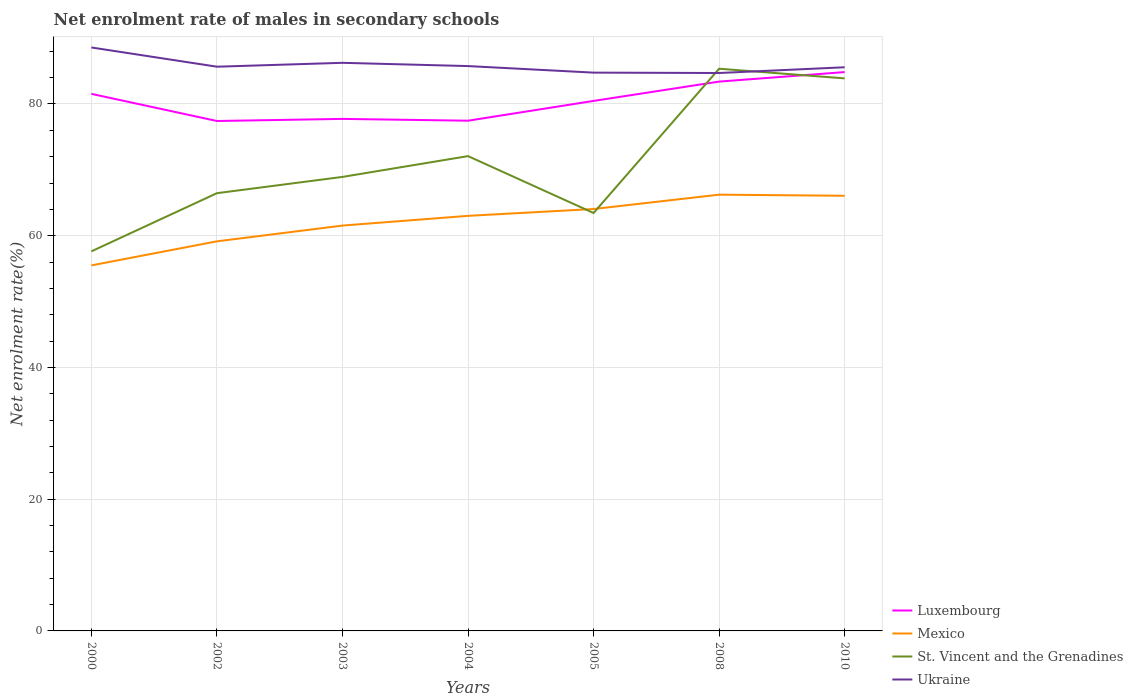How many different coloured lines are there?
Your response must be concise. 4. Does the line corresponding to St. Vincent and the Grenadines intersect with the line corresponding to Luxembourg?
Provide a short and direct response. Yes. Is the number of lines equal to the number of legend labels?
Offer a very short reply. Yes. Across all years, what is the maximum net enrolment rate of males in secondary schools in Mexico?
Your answer should be compact. 55.49. What is the total net enrolment rate of males in secondary schools in Mexico in the graph?
Give a very brief answer. 0.17. What is the difference between the highest and the second highest net enrolment rate of males in secondary schools in Luxembourg?
Your answer should be very brief. 7.42. Is the net enrolment rate of males in secondary schools in St. Vincent and the Grenadines strictly greater than the net enrolment rate of males in secondary schools in Luxembourg over the years?
Your answer should be compact. No. How many lines are there?
Offer a very short reply. 4. How many years are there in the graph?
Ensure brevity in your answer.  7. What is the difference between two consecutive major ticks on the Y-axis?
Make the answer very short. 20. Are the values on the major ticks of Y-axis written in scientific E-notation?
Your answer should be compact. No. Does the graph contain any zero values?
Give a very brief answer. No. Does the graph contain grids?
Ensure brevity in your answer.  Yes. How many legend labels are there?
Keep it short and to the point. 4. What is the title of the graph?
Make the answer very short. Net enrolment rate of males in secondary schools. What is the label or title of the Y-axis?
Your answer should be compact. Net enrolment rate(%). What is the Net enrolment rate(%) in Luxembourg in 2000?
Ensure brevity in your answer.  81.53. What is the Net enrolment rate(%) in Mexico in 2000?
Offer a very short reply. 55.49. What is the Net enrolment rate(%) of St. Vincent and the Grenadines in 2000?
Offer a very short reply. 57.63. What is the Net enrolment rate(%) of Ukraine in 2000?
Your answer should be very brief. 88.58. What is the Net enrolment rate(%) of Luxembourg in 2002?
Ensure brevity in your answer.  77.42. What is the Net enrolment rate(%) in Mexico in 2002?
Give a very brief answer. 59.15. What is the Net enrolment rate(%) in St. Vincent and the Grenadines in 2002?
Provide a succinct answer. 66.46. What is the Net enrolment rate(%) in Ukraine in 2002?
Offer a terse response. 85.66. What is the Net enrolment rate(%) in Luxembourg in 2003?
Give a very brief answer. 77.73. What is the Net enrolment rate(%) in Mexico in 2003?
Keep it short and to the point. 61.54. What is the Net enrolment rate(%) of St. Vincent and the Grenadines in 2003?
Provide a succinct answer. 68.93. What is the Net enrolment rate(%) of Ukraine in 2003?
Your answer should be very brief. 86.25. What is the Net enrolment rate(%) in Luxembourg in 2004?
Your answer should be very brief. 77.46. What is the Net enrolment rate(%) of Mexico in 2004?
Your answer should be compact. 63.02. What is the Net enrolment rate(%) in St. Vincent and the Grenadines in 2004?
Your response must be concise. 72.08. What is the Net enrolment rate(%) of Ukraine in 2004?
Your answer should be compact. 85.75. What is the Net enrolment rate(%) of Luxembourg in 2005?
Make the answer very short. 80.46. What is the Net enrolment rate(%) in Mexico in 2005?
Ensure brevity in your answer.  64.05. What is the Net enrolment rate(%) of St. Vincent and the Grenadines in 2005?
Your answer should be very brief. 63.45. What is the Net enrolment rate(%) of Ukraine in 2005?
Give a very brief answer. 84.76. What is the Net enrolment rate(%) in Luxembourg in 2008?
Offer a terse response. 83.4. What is the Net enrolment rate(%) of Mexico in 2008?
Keep it short and to the point. 66.23. What is the Net enrolment rate(%) of St. Vincent and the Grenadines in 2008?
Ensure brevity in your answer.  85.35. What is the Net enrolment rate(%) of Ukraine in 2008?
Keep it short and to the point. 84.7. What is the Net enrolment rate(%) in Luxembourg in 2010?
Provide a short and direct response. 84.84. What is the Net enrolment rate(%) in Mexico in 2010?
Offer a terse response. 66.06. What is the Net enrolment rate(%) of St. Vincent and the Grenadines in 2010?
Provide a short and direct response. 83.89. What is the Net enrolment rate(%) of Ukraine in 2010?
Make the answer very short. 85.57. Across all years, what is the maximum Net enrolment rate(%) in Luxembourg?
Give a very brief answer. 84.84. Across all years, what is the maximum Net enrolment rate(%) in Mexico?
Make the answer very short. 66.23. Across all years, what is the maximum Net enrolment rate(%) of St. Vincent and the Grenadines?
Provide a succinct answer. 85.35. Across all years, what is the maximum Net enrolment rate(%) of Ukraine?
Your answer should be compact. 88.58. Across all years, what is the minimum Net enrolment rate(%) of Luxembourg?
Make the answer very short. 77.42. Across all years, what is the minimum Net enrolment rate(%) in Mexico?
Your response must be concise. 55.49. Across all years, what is the minimum Net enrolment rate(%) in St. Vincent and the Grenadines?
Provide a short and direct response. 57.63. Across all years, what is the minimum Net enrolment rate(%) in Ukraine?
Keep it short and to the point. 84.7. What is the total Net enrolment rate(%) in Luxembourg in the graph?
Provide a short and direct response. 562.84. What is the total Net enrolment rate(%) of Mexico in the graph?
Your response must be concise. 435.54. What is the total Net enrolment rate(%) of St. Vincent and the Grenadines in the graph?
Make the answer very short. 497.78. What is the total Net enrolment rate(%) of Ukraine in the graph?
Give a very brief answer. 601.27. What is the difference between the Net enrolment rate(%) in Luxembourg in 2000 and that in 2002?
Offer a terse response. 4.12. What is the difference between the Net enrolment rate(%) in Mexico in 2000 and that in 2002?
Ensure brevity in your answer.  -3.65. What is the difference between the Net enrolment rate(%) in St. Vincent and the Grenadines in 2000 and that in 2002?
Offer a very short reply. -8.83. What is the difference between the Net enrolment rate(%) of Ukraine in 2000 and that in 2002?
Your answer should be compact. 2.92. What is the difference between the Net enrolment rate(%) of Luxembourg in 2000 and that in 2003?
Your answer should be compact. 3.8. What is the difference between the Net enrolment rate(%) in Mexico in 2000 and that in 2003?
Keep it short and to the point. -6.05. What is the difference between the Net enrolment rate(%) in St. Vincent and the Grenadines in 2000 and that in 2003?
Offer a terse response. -11.3. What is the difference between the Net enrolment rate(%) in Ukraine in 2000 and that in 2003?
Offer a very short reply. 2.33. What is the difference between the Net enrolment rate(%) in Luxembourg in 2000 and that in 2004?
Give a very brief answer. 4.07. What is the difference between the Net enrolment rate(%) in Mexico in 2000 and that in 2004?
Your response must be concise. -7.52. What is the difference between the Net enrolment rate(%) of St. Vincent and the Grenadines in 2000 and that in 2004?
Give a very brief answer. -14.46. What is the difference between the Net enrolment rate(%) in Ukraine in 2000 and that in 2004?
Keep it short and to the point. 2.83. What is the difference between the Net enrolment rate(%) of Luxembourg in 2000 and that in 2005?
Keep it short and to the point. 1.07. What is the difference between the Net enrolment rate(%) of Mexico in 2000 and that in 2005?
Make the answer very short. -8.56. What is the difference between the Net enrolment rate(%) of St. Vincent and the Grenadines in 2000 and that in 2005?
Offer a terse response. -5.82. What is the difference between the Net enrolment rate(%) in Ukraine in 2000 and that in 2005?
Offer a very short reply. 3.82. What is the difference between the Net enrolment rate(%) in Luxembourg in 2000 and that in 2008?
Your response must be concise. -1.86. What is the difference between the Net enrolment rate(%) in Mexico in 2000 and that in 2008?
Your answer should be compact. -10.74. What is the difference between the Net enrolment rate(%) in St. Vincent and the Grenadines in 2000 and that in 2008?
Provide a succinct answer. -27.73. What is the difference between the Net enrolment rate(%) in Ukraine in 2000 and that in 2008?
Ensure brevity in your answer.  3.87. What is the difference between the Net enrolment rate(%) in Luxembourg in 2000 and that in 2010?
Make the answer very short. -3.31. What is the difference between the Net enrolment rate(%) of Mexico in 2000 and that in 2010?
Keep it short and to the point. -10.57. What is the difference between the Net enrolment rate(%) in St. Vincent and the Grenadines in 2000 and that in 2010?
Your answer should be very brief. -26.26. What is the difference between the Net enrolment rate(%) of Ukraine in 2000 and that in 2010?
Provide a short and direct response. 3.01. What is the difference between the Net enrolment rate(%) in Luxembourg in 2002 and that in 2003?
Offer a very short reply. -0.32. What is the difference between the Net enrolment rate(%) in Mexico in 2002 and that in 2003?
Your response must be concise. -2.39. What is the difference between the Net enrolment rate(%) of St. Vincent and the Grenadines in 2002 and that in 2003?
Your answer should be compact. -2.47. What is the difference between the Net enrolment rate(%) of Ukraine in 2002 and that in 2003?
Your answer should be very brief. -0.59. What is the difference between the Net enrolment rate(%) of Luxembourg in 2002 and that in 2004?
Provide a succinct answer. -0.04. What is the difference between the Net enrolment rate(%) of Mexico in 2002 and that in 2004?
Your response must be concise. -3.87. What is the difference between the Net enrolment rate(%) of St. Vincent and the Grenadines in 2002 and that in 2004?
Offer a terse response. -5.63. What is the difference between the Net enrolment rate(%) of Ukraine in 2002 and that in 2004?
Your answer should be very brief. -0.09. What is the difference between the Net enrolment rate(%) in Luxembourg in 2002 and that in 2005?
Provide a short and direct response. -3.05. What is the difference between the Net enrolment rate(%) in Mexico in 2002 and that in 2005?
Offer a terse response. -4.91. What is the difference between the Net enrolment rate(%) of St. Vincent and the Grenadines in 2002 and that in 2005?
Keep it short and to the point. 3.01. What is the difference between the Net enrolment rate(%) in Ukraine in 2002 and that in 2005?
Provide a short and direct response. 0.9. What is the difference between the Net enrolment rate(%) in Luxembourg in 2002 and that in 2008?
Provide a short and direct response. -5.98. What is the difference between the Net enrolment rate(%) in Mexico in 2002 and that in 2008?
Make the answer very short. -7.08. What is the difference between the Net enrolment rate(%) in St. Vincent and the Grenadines in 2002 and that in 2008?
Your response must be concise. -18.89. What is the difference between the Net enrolment rate(%) of Ukraine in 2002 and that in 2008?
Your answer should be compact. 0.96. What is the difference between the Net enrolment rate(%) in Luxembourg in 2002 and that in 2010?
Ensure brevity in your answer.  -7.42. What is the difference between the Net enrolment rate(%) in Mexico in 2002 and that in 2010?
Your answer should be very brief. -6.92. What is the difference between the Net enrolment rate(%) in St. Vincent and the Grenadines in 2002 and that in 2010?
Your answer should be compact. -17.43. What is the difference between the Net enrolment rate(%) of Ukraine in 2002 and that in 2010?
Ensure brevity in your answer.  0.09. What is the difference between the Net enrolment rate(%) in Luxembourg in 2003 and that in 2004?
Ensure brevity in your answer.  0.28. What is the difference between the Net enrolment rate(%) of Mexico in 2003 and that in 2004?
Make the answer very short. -1.48. What is the difference between the Net enrolment rate(%) in St. Vincent and the Grenadines in 2003 and that in 2004?
Provide a succinct answer. -3.16. What is the difference between the Net enrolment rate(%) in Ukraine in 2003 and that in 2004?
Keep it short and to the point. 0.5. What is the difference between the Net enrolment rate(%) in Luxembourg in 2003 and that in 2005?
Your answer should be very brief. -2.73. What is the difference between the Net enrolment rate(%) of Mexico in 2003 and that in 2005?
Give a very brief answer. -2.51. What is the difference between the Net enrolment rate(%) in St. Vincent and the Grenadines in 2003 and that in 2005?
Your response must be concise. 5.48. What is the difference between the Net enrolment rate(%) of Ukraine in 2003 and that in 2005?
Offer a very short reply. 1.49. What is the difference between the Net enrolment rate(%) of Luxembourg in 2003 and that in 2008?
Provide a short and direct response. -5.66. What is the difference between the Net enrolment rate(%) of Mexico in 2003 and that in 2008?
Give a very brief answer. -4.69. What is the difference between the Net enrolment rate(%) in St. Vincent and the Grenadines in 2003 and that in 2008?
Give a very brief answer. -16.42. What is the difference between the Net enrolment rate(%) in Ukraine in 2003 and that in 2008?
Make the answer very short. 1.54. What is the difference between the Net enrolment rate(%) of Luxembourg in 2003 and that in 2010?
Make the answer very short. -7.11. What is the difference between the Net enrolment rate(%) of Mexico in 2003 and that in 2010?
Ensure brevity in your answer.  -4.53. What is the difference between the Net enrolment rate(%) in St. Vincent and the Grenadines in 2003 and that in 2010?
Keep it short and to the point. -14.96. What is the difference between the Net enrolment rate(%) in Ukraine in 2003 and that in 2010?
Offer a terse response. 0.68. What is the difference between the Net enrolment rate(%) in Luxembourg in 2004 and that in 2005?
Give a very brief answer. -3.01. What is the difference between the Net enrolment rate(%) of Mexico in 2004 and that in 2005?
Provide a succinct answer. -1.04. What is the difference between the Net enrolment rate(%) of St. Vincent and the Grenadines in 2004 and that in 2005?
Your answer should be very brief. 8.64. What is the difference between the Net enrolment rate(%) in Ukraine in 2004 and that in 2005?
Provide a short and direct response. 0.99. What is the difference between the Net enrolment rate(%) in Luxembourg in 2004 and that in 2008?
Give a very brief answer. -5.94. What is the difference between the Net enrolment rate(%) of Mexico in 2004 and that in 2008?
Provide a short and direct response. -3.21. What is the difference between the Net enrolment rate(%) of St. Vincent and the Grenadines in 2004 and that in 2008?
Your answer should be compact. -13.27. What is the difference between the Net enrolment rate(%) of Ukraine in 2004 and that in 2008?
Your answer should be very brief. 1.05. What is the difference between the Net enrolment rate(%) in Luxembourg in 2004 and that in 2010?
Your response must be concise. -7.38. What is the difference between the Net enrolment rate(%) in Mexico in 2004 and that in 2010?
Give a very brief answer. -3.05. What is the difference between the Net enrolment rate(%) of St. Vincent and the Grenadines in 2004 and that in 2010?
Give a very brief answer. -11.8. What is the difference between the Net enrolment rate(%) of Ukraine in 2004 and that in 2010?
Make the answer very short. 0.18. What is the difference between the Net enrolment rate(%) of Luxembourg in 2005 and that in 2008?
Your answer should be compact. -2.93. What is the difference between the Net enrolment rate(%) of Mexico in 2005 and that in 2008?
Your response must be concise. -2.18. What is the difference between the Net enrolment rate(%) in St. Vincent and the Grenadines in 2005 and that in 2008?
Keep it short and to the point. -21.9. What is the difference between the Net enrolment rate(%) of Ukraine in 2005 and that in 2008?
Your answer should be very brief. 0.06. What is the difference between the Net enrolment rate(%) in Luxembourg in 2005 and that in 2010?
Offer a terse response. -4.38. What is the difference between the Net enrolment rate(%) in Mexico in 2005 and that in 2010?
Provide a short and direct response. -2.01. What is the difference between the Net enrolment rate(%) of St. Vincent and the Grenadines in 2005 and that in 2010?
Your answer should be very brief. -20.44. What is the difference between the Net enrolment rate(%) in Ukraine in 2005 and that in 2010?
Provide a succinct answer. -0.81. What is the difference between the Net enrolment rate(%) in Luxembourg in 2008 and that in 2010?
Offer a very short reply. -1.44. What is the difference between the Net enrolment rate(%) in Mexico in 2008 and that in 2010?
Your answer should be compact. 0.17. What is the difference between the Net enrolment rate(%) of St. Vincent and the Grenadines in 2008 and that in 2010?
Your answer should be compact. 1.47. What is the difference between the Net enrolment rate(%) of Ukraine in 2008 and that in 2010?
Ensure brevity in your answer.  -0.87. What is the difference between the Net enrolment rate(%) in Luxembourg in 2000 and the Net enrolment rate(%) in Mexico in 2002?
Your response must be concise. 22.39. What is the difference between the Net enrolment rate(%) in Luxembourg in 2000 and the Net enrolment rate(%) in St. Vincent and the Grenadines in 2002?
Give a very brief answer. 15.08. What is the difference between the Net enrolment rate(%) of Luxembourg in 2000 and the Net enrolment rate(%) of Ukraine in 2002?
Offer a very short reply. -4.13. What is the difference between the Net enrolment rate(%) in Mexico in 2000 and the Net enrolment rate(%) in St. Vincent and the Grenadines in 2002?
Provide a succinct answer. -10.96. What is the difference between the Net enrolment rate(%) in Mexico in 2000 and the Net enrolment rate(%) in Ukraine in 2002?
Provide a short and direct response. -30.17. What is the difference between the Net enrolment rate(%) in St. Vincent and the Grenadines in 2000 and the Net enrolment rate(%) in Ukraine in 2002?
Your answer should be very brief. -28.03. What is the difference between the Net enrolment rate(%) of Luxembourg in 2000 and the Net enrolment rate(%) of Mexico in 2003?
Your answer should be compact. 19.99. What is the difference between the Net enrolment rate(%) of Luxembourg in 2000 and the Net enrolment rate(%) of St. Vincent and the Grenadines in 2003?
Offer a terse response. 12.61. What is the difference between the Net enrolment rate(%) in Luxembourg in 2000 and the Net enrolment rate(%) in Ukraine in 2003?
Provide a succinct answer. -4.71. What is the difference between the Net enrolment rate(%) in Mexico in 2000 and the Net enrolment rate(%) in St. Vincent and the Grenadines in 2003?
Your response must be concise. -13.43. What is the difference between the Net enrolment rate(%) of Mexico in 2000 and the Net enrolment rate(%) of Ukraine in 2003?
Keep it short and to the point. -30.75. What is the difference between the Net enrolment rate(%) in St. Vincent and the Grenadines in 2000 and the Net enrolment rate(%) in Ukraine in 2003?
Keep it short and to the point. -28.62. What is the difference between the Net enrolment rate(%) of Luxembourg in 2000 and the Net enrolment rate(%) of Mexico in 2004?
Keep it short and to the point. 18.52. What is the difference between the Net enrolment rate(%) in Luxembourg in 2000 and the Net enrolment rate(%) in St. Vincent and the Grenadines in 2004?
Make the answer very short. 9.45. What is the difference between the Net enrolment rate(%) in Luxembourg in 2000 and the Net enrolment rate(%) in Ukraine in 2004?
Give a very brief answer. -4.22. What is the difference between the Net enrolment rate(%) in Mexico in 2000 and the Net enrolment rate(%) in St. Vincent and the Grenadines in 2004?
Ensure brevity in your answer.  -16.59. What is the difference between the Net enrolment rate(%) in Mexico in 2000 and the Net enrolment rate(%) in Ukraine in 2004?
Your response must be concise. -30.26. What is the difference between the Net enrolment rate(%) of St. Vincent and the Grenadines in 2000 and the Net enrolment rate(%) of Ukraine in 2004?
Give a very brief answer. -28.13. What is the difference between the Net enrolment rate(%) of Luxembourg in 2000 and the Net enrolment rate(%) of Mexico in 2005?
Give a very brief answer. 17.48. What is the difference between the Net enrolment rate(%) of Luxembourg in 2000 and the Net enrolment rate(%) of St. Vincent and the Grenadines in 2005?
Keep it short and to the point. 18.09. What is the difference between the Net enrolment rate(%) of Luxembourg in 2000 and the Net enrolment rate(%) of Ukraine in 2005?
Ensure brevity in your answer.  -3.23. What is the difference between the Net enrolment rate(%) in Mexico in 2000 and the Net enrolment rate(%) in St. Vincent and the Grenadines in 2005?
Provide a succinct answer. -7.95. What is the difference between the Net enrolment rate(%) of Mexico in 2000 and the Net enrolment rate(%) of Ukraine in 2005?
Keep it short and to the point. -29.27. What is the difference between the Net enrolment rate(%) of St. Vincent and the Grenadines in 2000 and the Net enrolment rate(%) of Ukraine in 2005?
Offer a very short reply. -27.13. What is the difference between the Net enrolment rate(%) in Luxembourg in 2000 and the Net enrolment rate(%) in Mexico in 2008?
Offer a terse response. 15.3. What is the difference between the Net enrolment rate(%) of Luxembourg in 2000 and the Net enrolment rate(%) of St. Vincent and the Grenadines in 2008?
Offer a terse response. -3.82. What is the difference between the Net enrolment rate(%) in Luxembourg in 2000 and the Net enrolment rate(%) in Ukraine in 2008?
Your answer should be compact. -3.17. What is the difference between the Net enrolment rate(%) in Mexico in 2000 and the Net enrolment rate(%) in St. Vincent and the Grenadines in 2008?
Keep it short and to the point. -29.86. What is the difference between the Net enrolment rate(%) in Mexico in 2000 and the Net enrolment rate(%) in Ukraine in 2008?
Your answer should be compact. -29.21. What is the difference between the Net enrolment rate(%) in St. Vincent and the Grenadines in 2000 and the Net enrolment rate(%) in Ukraine in 2008?
Offer a very short reply. -27.08. What is the difference between the Net enrolment rate(%) in Luxembourg in 2000 and the Net enrolment rate(%) in Mexico in 2010?
Your answer should be very brief. 15.47. What is the difference between the Net enrolment rate(%) of Luxembourg in 2000 and the Net enrolment rate(%) of St. Vincent and the Grenadines in 2010?
Give a very brief answer. -2.35. What is the difference between the Net enrolment rate(%) of Luxembourg in 2000 and the Net enrolment rate(%) of Ukraine in 2010?
Provide a succinct answer. -4.04. What is the difference between the Net enrolment rate(%) in Mexico in 2000 and the Net enrolment rate(%) in St. Vincent and the Grenadines in 2010?
Make the answer very short. -28.39. What is the difference between the Net enrolment rate(%) of Mexico in 2000 and the Net enrolment rate(%) of Ukraine in 2010?
Your answer should be compact. -30.08. What is the difference between the Net enrolment rate(%) in St. Vincent and the Grenadines in 2000 and the Net enrolment rate(%) in Ukraine in 2010?
Your response must be concise. -27.95. What is the difference between the Net enrolment rate(%) of Luxembourg in 2002 and the Net enrolment rate(%) of Mexico in 2003?
Make the answer very short. 15.88. What is the difference between the Net enrolment rate(%) in Luxembourg in 2002 and the Net enrolment rate(%) in St. Vincent and the Grenadines in 2003?
Ensure brevity in your answer.  8.49. What is the difference between the Net enrolment rate(%) in Luxembourg in 2002 and the Net enrolment rate(%) in Ukraine in 2003?
Ensure brevity in your answer.  -8.83. What is the difference between the Net enrolment rate(%) of Mexico in 2002 and the Net enrolment rate(%) of St. Vincent and the Grenadines in 2003?
Ensure brevity in your answer.  -9.78. What is the difference between the Net enrolment rate(%) of Mexico in 2002 and the Net enrolment rate(%) of Ukraine in 2003?
Provide a short and direct response. -27.1. What is the difference between the Net enrolment rate(%) in St. Vincent and the Grenadines in 2002 and the Net enrolment rate(%) in Ukraine in 2003?
Give a very brief answer. -19.79. What is the difference between the Net enrolment rate(%) of Luxembourg in 2002 and the Net enrolment rate(%) of Mexico in 2004?
Ensure brevity in your answer.  14.4. What is the difference between the Net enrolment rate(%) in Luxembourg in 2002 and the Net enrolment rate(%) in St. Vincent and the Grenadines in 2004?
Provide a short and direct response. 5.33. What is the difference between the Net enrolment rate(%) in Luxembourg in 2002 and the Net enrolment rate(%) in Ukraine in 2004?
Ensure brevity in your answer.  -8.34. What is the difference between the Net enrolment rate(%) of Mexico in 2002 and the Net enrolment rate(%) of St. Vincent and the Grenadines in 2004?
Give a very brief answer. -12.94. What is the difference between the Net enrolment rate(%) of Mexico in 2002 and the Net enrolment rate(%) of Ukraine in 2004?
Offer a terse response. -26.61. What is the difference between the Net enrolment rate(%) of St. Vincent and the Grenadines in 2002 and the Net enrolment rate(%) of Ukraine in 2004?
Offer a terse response. -19.3. What is the difference between the Net enrolment rate(%) of Luxembourg in 2002 and the Net enrolment rate(%) of Mexico in 2005?
Your answer should be compact. 13.36. What is the difference between the Net enrolment rate(%) in Luxembourg in 2002 and the Net enrolment rate(%) in St. Vincent and the Grenadines in 2005?
Offer a terse response. 13.97. What is the difference between the Net enrolment rate(%) of Luxembourg in 2002 and the Net enrolment rate(%) of Ukraine in 2005?
Your response must be concise. -7.34. What is the difference between the Net enrolment rate(%) in Mexico in 2002 and the Net enrolment rate(%) in St. Vincent and the Grenadines in 2005?
Provide a succinct answer. -4.3. What is the difference between the Net enrolment rate(%) of Mexico in 2002 and the Net enrolment rate(%) of Ukraine in 2005?
Your answer should be compact. -25.61. What is the difference between the Net enrolment rate(%) of St. Vincent and the Grenadines in 2002 and the Net enrolment rate(%) of Ukraine in 2005?
Your answer should be compact. -18.3. What is the difference between the Net enrolment rate(%) in Luxembourg in 2002 and the Net enrolment rate(%) in Mexico in 2008?
Make the answer very short. 11.18. What is the difference between the Net enrolment rate(%) of Luxembourg in 2002 and the Net enrolment rate(%) of St. Vincent and the Grenadines in 2008?
Your response must be concise. -7.94. What is the difference between the Net enrolment rate(%) in Luxembourg in 2002 and the Net enrolment rate(%) in Ukraine in 2008?
Keep it short and to the point. -7.29. What is the difference between the Net enrolment rate(%) in Mexico in 2002 and the Net enrolment rate(%) in St. Vincent and the Grenadines in 2008?
Provide a succinct answer. -26.2. What is the difference between the Net enrolment rate(%) in Mexico in 2002 and the Net enrolment rate(%) in Ukraine in 2008?
Offer a terse response. -25.56. What is the difference between the Net enrolment rate(%) of St. Vincent and the Grenadines in 2002 and the Net enrolment rate(%) of Ukraine in 2008?
Ensure brevity in your answer.  -18.25. What is the difference between the Net enrolment rate(%) in Luxembourg in 2002 and the Net enrolment rate(%) in Mexico in 2010?
Ensure brevity in your answer.  11.35. What is the difference between the Net enrolment rate(%) of Luxembourg in 2002 and the Net enrolment rate(%) of St. Vincent and the Grenadines in 2010?
Provide a succinct answer. -6.47. What is the difference between the Net enrolment rate(%) of Luxembourg in 2002 and the Net enrolment rate(%) of Ukraine in 2010?
Keep it short and to the point. -8.16. What is the difference between the Net enrolment rate(%) of Mexico in 2002 and the Net enrolment rate(%) of St. Vincent and the Grenadines in 2010?
Ensure brevity in your answer.  -24.74. What is the difference between the Net enrolment rate(%) of Mexico in 2002 and the Net enrolment rate(%) of Ukraine in 2010?
Provide a succinct answer. -26.43. What is the difference between the Net enrolment rate(%) in St. Vincent and the Grenadines in 2002 and the Net enrolment rate(%) in Ukraine in 2010?
Keep it short and to the point. -19.12. What is the difference between the Net enrolment rate(%) of Luxembourg in 2003 and the Net enrolment rate(%) of Mexico in 2004?
Ensure brevity in your answer.  14.72. What is the difference between the Net enrolment rate(%) in Luxembourg in 2003 and the Net enrolment rate(%) in St. Vincent and the Grenadines in 2004?
Ensure brevity in your answer.  5.65. What is the difference between the Net enrolment rate(%) in Luxembourg in 2003 and the Net enrolment rate(%) in Ukraine in 2004?
Keep it short and to the point. -8.02. What is the difference between the Net enrolment rate(%) of Mexico in 2003 and the Net enrolment rate(%) of St. Vincent and the Grenadines in 2004?
Your answer should be compact. -10.54. What is the difference between the Net enrolment rate(%) in Mexico in 2003 and the Net enrolment rate(%) in Ukraine in 2004?
Give a very brief answer. -24.21. What is the difference between the Net enrolment rate(%) in St. Vincent and the Grenadines in 2003 and the Net enrolment rate(%) in Ukraine in 2004?
Provide a short and direct response. -16.83. What is the difference between the Net enrolment rate(%) of Luxembourg in 2003 and the Net enrolment rate(%) of Mexico in 2005?
Your answer should be compact. 13.68. What is the difference between the Net enrolment rate(%) in Luxembourg in 2003 and the Net enrolment rate(%) in St. Vincent and the Grenadines in 2005?
Offer a very short reply. 14.29. What is the difference between the Net enrolment rate(%) in Luxembourg in 2003 and the Net enrolment rate(%) in Ukraine in 2005?
Offer a terse response. -7.03. What is the difference between the Net enrolment rate(%) in Mexico in 2003 and the Net enrolment rate(%) in St. Vincent and the Grenadines in 2005?
Your answer should be very brief. -1.91. What is the difference between the Net enrolment rate(%) in Mexico in 2003 and the Net enrolment rate(%) in Ukraine in 2005?
Provide a short and direct response. -23.22. What is the difference between the Net enrolment rate(%) in St. Vincent and the Grenadines in 2003 and the Net enrolment rate(%) in Ukraine in 2005?
Make the answer very short. -15.83. What is the difference between the Net enrolment rate(%) of Luxembourg in 2003 and the Net enrolment rate(%) of Mexico in 2008?
Your answer should be very brief. 11.5. What is the difference between the Net enrolment rate(%) of Luxembourg in 2003 and the Net enrolment rate(%) of St. Vincent and the Grenadines in 2008?
Your response must be concise. -7.62. What is the difference between the Net enrolment rate(%) of Luxembourg in 2003 and the Net enrolment rate(%) of Ukraine in 2008?
Your answer should be very brief. -6.97. What is the difference between the Net enrolment rate(%) in Mexico in 2003 and the Net enrolment rate(%) in St. Vincent and the Grenadines in 2008?
Provide a succinct answer. -23.81. What is the difference between the Net enrolment rate(%) in Mexico in 2003 and the Net enrolment rate(%) in Ukraine in 2008?
Give a very brief answer. -23.16. What is the difference between the Net enrolment rate(%) of St. Vincent and the Grenadines in 2003 and the Net enrolment rate(%) of Ukraine in 2008?
Keep it short and to the point. -15.78. What is the difference between the Net enrolment rate(%) in Luxembourg in 2003 and the Net enrolment rate(%) in Mexico in 2010?
Your answer should be compact. 11.67. What is the difference between the Net enrolment rate(%) of Luxembourg in 2003 and the Net enrolment rate(%) of St. Vincent and the Grenadines in 2010?
Ensure brevity in your answer.  -6.15. What is the difference between the Net enrolment rate(%) in Luxembourg in 2003 and the Net enrolment rate(%) in Ukraine in 2010?
Your answer should be very brief. -7.84. What is the difference between the Net enrolment rate(%) in Mexico in 2003 and the Net enrolment rate(%) in St. Vincent and the Grenadines in 2010?
Provide a short and direct response. -22.35. What is the difference between the Net enrolment rate(%) in Mexico in 2003 and the Net enrolment rate(%) in Ukraine in 2010?
Provide a short and direct response. -24.03. What is the difference between the Net enrolment rate(%) of St. Vincent and the Grenadines in 2003 and the Net enrolment rate(%) of Ukraine in 2010?
Provide a succinct answer. -16.65. What is the difference between the Net enrolment rate(%) in Luxembourg in 2004 and the Net enrolment rate(%) in Mexico in 2005?
Offer a terse response. 13.41. What is the difference between the Net enrolment rate(%) in Luxembourg in 2004 and the Net enrolment rate(%) in St. Vincent and the Grenadines in 2005?
Your answer should be compact. 14.01. What is the difference between the Net enrolment rate(%) in Luxembourg in 2004 and the Net enrolment rate(%) in Ukraine in 2005?
Your response must be concise. -7.3. What is the difference between the Net enrolment rate(%) in Mexico in 2004 and the Net enrolment rate(%) in St. Vincent and the Grenadines in 2005?
Provide a short and direct response. -0.43. What is the difference between the Net enrolment rate(%) of Mexico in 2004 and the Net enrolment rate(%) of Ukraine in 2005?
Your response must be concise. -21.74. What is the difference between the Net enrolment rate(%) in St. Vincent and the Grenadines in 2004 and the Net enrolment rate(%) in Ukraine in 2005?
Offer a terse response. -12.68. What is the difference between the Net enrolment rate(%) in Luxembourg in 2004 and the Net enrolment rate(%) in Mexico in 2008?
Offer a very short reply. 11.23. What is the difference between the Net enrolment rate(%) of Luxembourg in 2004 and the Net enrolment rate(%) of St. Vincent and the Grenadines in 2008?
Offer a terse response. -7.89. What is the difference between the Net enrolment rate(%) of Luxembourg in 2004 and the Net enrolment rate(%) of Ukraine in 2008?
Offer a terse response. -7.24. What is the difference between the Net enrolment rate(%) of Mexico in 2004 and the Net enrolment rate(%) of St. Vincent and the Grenadines in 2008?
Give a very brief answer. -22.33. What is the difference between the Net enrolment rate(%) in Mexico in 2004 and the Net enrolment rate(%) in Ukraine in 2008?
Your response must be concise. -21.69. What is the difference between the Net enrolment rate(%) in St. Vincent and the Grenadines in 2004 and the Net enrolment rate(%) in Ukraine in 2008?
Make the answer very short. -12.62. What is the difference between the Net enrolment rate(%) of Luxembourg in 2004 and the Net enrolment rate(%) of Mexico in 2010?
Keep it short and to the point. 11.39. What is the difference between the Net enrolment rate(%) of Luxembourg in 2004 and the Net enrolment rate(%) of St. Vincent and the Grenadines in 2010?
Offer a very short reply. -6.43. What is the difference between the Net enrolment rate(%) of Luxembourg in 2004 and the Net enrolment rate(%) of Ukraine in 2010?
Your answer should be very brief. -8.11. What is the difference between the Net enrolment rate(%) in Mexico in 2004 and the Net enrolment rate(%) in St. Vincent and the Grenadines in 2010?
Give a very brief answer. -20.87. What is the difference between the Net enrolment rate(%) in Mexico in 2004 and the Net enrolment rate(%) in Ukraine in 2010?
Provide a short and direct response. -22.56. What is the difference between the Net enrolment rate(%) of St. Vincent and the Grenadines in 2004 and the Net enrolment rate(%) of Ukraine in 2010?
Offer a very short reply. -13.49. What is the difference between the Net enrolment rate(%) of Luxembourg in 2005 and the Net enrolment rate(%) of Mexico in 2008?
Offer a terse response. 14.23. What is the difference between the Net enrolment rate(%) of Luxembourg in 2005 and the Net enrolment rate(%) of St. Vincent and the Grenadines in 2008?
Ensure brevity in your answer.  -4.89. What is the difference between the Net enrolment rate(%) in Luxembourg in 2005 and the Net enrolment rate(%) in Ukraine in 2008?
Offer a very short reply. -4.24. What is the difference between the Net enrolment rate(%) in Mexico in 2005 and the Net enrolment rate(%) in St. Vincent and the Grenadines in 2008?
Ensure brevity in your answer.  -21.3. What is the difference between the Net enrolment rate(%) of Mexico in 2005 and the Net enrolment rate(%) of Ukraine in 2008?
Give a very brief answer. -20.65. What is the difference between the Net enrolment rate(%) of St. Vincent and the Grenadines in 2005 and the Net enrolment rate(%) of Ukraine in 2008?
Ensure brevity in your answer.  -21.26. What is the difference between the Net enrolment rate(%) in Luxembourg in 2005 and the Net enrolment rate(%) in Mexico in 2010?
Provide a short and direct response. 14.4. What is the difference between the Net enrolment rate(%) of Luxembourg in 2005 and the Net enrolment rate(%) of St. Vincent and the Grenadines in 2010?
Your response must be concise. -3.42. What is the difference between the Net enrolment rate(%) of Luxembourg in 2005 and the Net enrolment rate(%) of Ukraine in 2010?
Your answer should be compact. -5.11. What is the difference between the Net enrolment rate(%) of Mexico in 2005 and the Net enrolment rate(%) of St. Vincent and the Grenadines in 2010?
Keep it short and to the point. -19.83. What is the difference between the Net enrolment rate(%) of Mexico in 2005 and the Net enrolment rate(%) of Ukraine in 2010?
Offer a very short reply. -21.52. What is the difference between the Net enrolment rate(%) in St. Vincent and the Grenadines in 2005 and the Net enrolment rate(%) in Ukraine in 2010?
Keep it short and to the point. -22.13. What is the difference between the Net enrolment rate(%) in Luxembourg in 2008 and the Net enrolment rate(%) in Mexico in 2010?
Provide a short and direct response. 17.33. What is the difference between the Net enrolment rate(%) of Luxembourg in 2008 and the Net enrolment rate(%) of St. Vincent and the Grenadines in 2010?
Provide a succinct answer. -0.49. What is the difference between the Net enrolment rate(%) in Luxembourg in 2008 and the Net enrolment rate(%) in Ukraine in 2010?
Make the answer very short. -2.17. What is the difference between the Net enrolment rate(%) in Mexico in 2008 and the Net enrolment rate(%) in St. Vincent and the Grenadines in 2010?
Make the answer very short. -17.66. What is the difference between the Net enrolment rate(%) of Mexico in 2008 and the Net enrolment rate(%) of Ukraine in 2010?
Provide a short and direct response. -19.34. What is the difference between the Net enrolment rate(%) of St. Vincent and the Grenadines in 2008 and the Net enrolment rate(%) of Ukraine in 2010?
Give a very brief answer. -0.22. What is the average Net enrolment rate(%) in Luxembourg per year?
Your answer should be very brief. 80.41. What is the average Net enrolment rate(%) of Mexico per year?
Give a very brief answer. 62.22. What is the average Net enrolment rate(%) in St. Vincent and the Grenadines per year?
Your answer should be compact. 71.11. What is the average Net enrolment rate(%) of Ukraine per year?
Give a very brief answer. 85.9. In the year 2000, what is the difference between the Net enrolment rate(%) in Luxembourg and Net enrolment rate(%) in Mexico?
Offer a very short reply. 26.04. In the year 2000, what is the difference between the Net enrolment rate(%) in Luxembourg and Net enrolment rate(%) in St. Vincent and the Grenadines?
Your answer should be very brief. 23.91. In the year 2000, what is the difference between the Net enrolment rate(%) of Luxembourg and Net enrolment rate(%) of Ukraine?
Keep it short and to the point. -7.04. In the year 2000, what is the difference between the Net enrolment rate(%) of Mexico and Net enrolment rate(%) of St. Vincent and the Grenadines?
Give a very brief answer. -2.13. In the year 2000, what is the difference between the Net enrolment rate(%) of Mexico and Net enrolment rate(%) of Ukraine?
Keep it short and to the point. -33.08. In the year 2000, what is the difference between the Net enrolment rate(%) in St. Vincent and the Grenadines and Net enrolment rate(%) in Ukraine?
Keep it short and to the point. -30.95. In the year 2002, what is the difference between the Net enrolment rate(%) of Luxembourg and Net enrolment rate(%) of Mexico?
Keep it short and to the point. 18.27. In the year 2002, what is the difference between the Net enrolment rate(%) of Luxembourg and Net enrolment rate(%) of St. Vincent and the Grenadines?
Ensure brevity in your answer.  10.96. In the year 2002, what is the difference between the Net enrolment rate(%) of Luxembourg and Net enrolment rate(%) of Ukraine?
Give a very brief answer. -8.24. In the year 2002, what is the difference between the Net enrolment rate(%) of Mexico and Net enrolment rate(%) of St. Vincent and the Grenadines?
Your answer should be compact. -7.31. In the year 2002, what is the difference between the Net enrolment rate(%) in Mexico and Net enrolment rate(%) in Ukraine?
Keep it short and to the point. -26.51. In the year 2002, what is the difference between the Net enrolment rate(%) in St. Vincent and the Grenadines and Net enrolment rate(%) in Ukraine?
Offer a terse response. -19.2. In the year 2003, what is the difference between the Net enrolment rate(%) in Luxembourg and Net enrolment rate(%) in Mexico?
Provide a succinct answer. 16.2. In the year 2003, what is the difference between the Net enrolment rate(%) in Luxembourg and Net enrolment rate(%) in St. Vincent and the Grenadines?
Your answer should be compact. 8.81. In the year 2003, what is the difference between the Net enrolment rate(%) of Luxembourg and Net enrolment rate(%) of Ukraine?
Give a very brief answer. -8.51. In the year 2003, what is the difference between the Net enrolment rate(%) in Mexico and Net enrolment rate(%) in St. Vincent and the Grenadines?
Offer a terse response. -7.39. In the year 2003, what is the difference between the Net enrolment rate(%) of Mexico and Net enrolment rate(%) of Ukraine?
Your response must be concise. -24.71. In the year 2003, what is the difference between the Net enrolment rate(%) of St. Vincent and the Grenadines and Net enrolment rate(%) of Ukraine?
Make the answer very short. -17.32. In the year 2004, what is the difference between the Net enrolment rate(%) in Luxembourg and Net enrolment rate(%) in Mexico?
Provide a short and direct response. 14.44. In the year 2004, what is the difference between the Net enrolment rate(%) in Luxembourg and Net enrolment rate(%) in St. Vincent and the Grenadines?
Offer a terse response. 5.37. In the year 2004, what is the difference between the Net enrolment rate(%) of Luxembourg and Net enrolment rate(%) of Ukraine?
Offer a very short reply. -8.29. In the year 2004, what is the difference between the Net enrolment rate(%) of Mexico and Net enrolment rate(%) of St. Vincent and the Grenadines?
Keep it short and to the point. -9.07. In the year 2004, what is the difference between the Net enrolment rate(%) in Mexico and Net enrolment rate(%) in Ukraine?
Provide a short and direct response. -22.74. In the year 2004, what is the difference between the Net enrolment rate(%) of St. Vincent and the Grenadines and Net enrolment rate(%) of Ukraine?
Your answer should be compact. -13.67. In the year 2005, what is the difference between the Net enrolment rate(%) in Luxembourg and Net enrolment rate(%) in Mexico?
Provide a short and direct response. 16.41. In the year 2005, what is the difference between the Net enrolment rate(%) in Luxembourg and Net enrolment rate(%) in St. Vincent and the Grenadines?
Your answer should be compact. 17.02. In the year 2005, what is the difference between the Net enrolment rate(%) in Luxembourg and Net enrolment rate(%) in Ukraine?
Give a very brief answer. -4.3. In the year 2005, what is the difference between the Net enrolment rate(%) in Mexico and Net enrolment rate(%) in St. Vincent and the Grenadines?
Offer a very short reply. 0.61. In the year 2005, what is the difference between the Net enrolment rate(%) in Mexico and Net enrolment rate(%) in Ukraine?
Provide a short and direct response. -20.71. In the year 2005, what is the difference between the Net enrolment rate(%) in St. Vincent and the Grenadines and Net enrolment rate(%) in Ukraine?
Your answer should be very brief. -21.31. In the year 2008, what is the difference between the Net enrolment rate(%) in Luxembourg and Net enrolment rate(%) in Mexico?
Provide a succinct answer. 17.17. In the year 2008, what is the difference between the Net enrolment rate(%) of Luxembourg and Net enrolment rate(%) of St. Vincent and the Grenadines?
Ensure brevity in your answer.  -1.95. In the year 2008, what is the difference between the Net enrolment rate(%) in Luxembourg and Net enrolment rate(%) in Ukraine?
Give a very brief answer. -1.31. In the year 2008, what is the difference between the Net enrolment rate(%) of Mexico and Net enrolment rate(%) of St. Vincent and the Grenadines?
Provide a short and direct response. -19.12. In the year 2008, what is the difference between the Net enrolment rate(%) of Mexico and Net enrolment rate(%) of Ukraine?
Keep it short and to the point. -18.47. In the year 2008, what is the difference between the Net enrolment rate(%) of St. Vincent and the Grenadines and Net enrolment rate(%) of Ukraine?
Ensure brevity in your answer.  0.65. In the year 2010, what is the difference between the Net enrolment rate(%) of Luxembourg and Net enrolment rate(%) of Mexico?
Make the answer very short. 18.78. In the year 2010, what is the difference between the Net enrolment rate(%) in Luxembourg and Net enrolment rate(%) in St. Vincent and the Grenadines?
Your response must be concise. 0.95. In the year 2010, what is the difference between the Net enrolment rate(%) in Luxembourg and Net enrolment rate(%) in Ukraine?
Keep it short and to the point. -0.73. In the year 2010, what is the difference between the Net enrolment rate(%) in Mexico and Net enrolment rate(%) in St. Vincent and the Grenadines?
Ensure brevity in your answer.  -17.82. In the year 2010, what is the difference between the Net enrolment rate(%) in Mexico and Net enrolment rate(%) in Ukraine?
Provide a short and direct response. -19.51. In the year 2010, what is the difference between the Net enrolment rate(%) in St. Vincent and the Grenadines and Net enrolment rate(%) in Ukraine?
Your response must be concise. -1.69. What is the ratio of the Net enrolment rate(%) of Luxembourg in 2000 to that in 2002?
Provide a short and direct response. 1.05. What is the ratio of the Net enrolment rate(%) in Mexico in 2000 to that in 2002?
Provide a short and direct response. 0.94. What is the ratio of the Net enrolment rate(%) in St. Vincent and the Grenadines in 2000 to that in 2002?
Provide a succinct answer. 0.87. What is the ratio of the Net enrolment rate(%) of Ukraine in 2000 to that in 2002?
Provide a succinct answer. 1.03. What is the ratio of the Net enrolment rate(%) in Luxembourg in 2000 to that in 2003?
Keep it short and to the point. 1.05. What is the ratio of the Net enrolment rate(%) in Mexico in 2000 to that in 2003?
Offer a terse response. 0.9. What is the ratio of the Net enrolment rate(%) of St. Vincent and the Grenadines in 2000 to that in 2003?
Keep it short and to the point. 0.84. What is the ratio of the Net enrolment rate(%) in Ukraine in 2000 to that in 2003?
Ensure brevity in your answer.  1.03. What is the ratio of the Net enrolment rate(%) of Luxembourg in 2000 to that in 2004?
Ensure brevity in your answer.  1.05. What is the ratio of the Net enrolment rate(%) of Mexico in 2000 to that in 2004?
Ensure brevity in your answer.  0.88. What is the ratio of the Net enrolment rate(%) in St. Vincent and the Grenadines in 2000 to that in 2004?
Your answer should be compact. 0.8. What is the ratio of the Net enrolment rate(%) in Ukraine in 2000 to that in 2004?
Keep it short and to the point. 1.03. What is the ratio of the Net enrolment rate(%) of Luxembourg in 2000 to that in 2005?
Provide a short and direct response. 1.01. What is the ratio of the Net enrolment rate(%) of Mexico in 2000 to that in 2005?
Give a very brief answer. 0.87. What is the ratio of the Net enrolment rate(%) in St. Vincent and the Grenadines in 2000 to that in 2005?
Provide a short and direct response. 0.91. What is the ratio of the Net enrolment rate(%) in Ukraine in 2000 to that in 2005?
Offer a terse response. 1.04. What is the ratio of the Net enrolment rate(%) in Luxembourg in 2000 to that in 2008?
Provide a short and direct response. 0.98. What is the ratio of the Net enrolment rate(%) of Mexico in 2000 to that in 2008?
Keep it short and to the point. 0.84. What is the ratio of the Net enrolment rate(%) of St. Vincent and the Grenadines in 2000 to that in 2008?
Your answer should be very brief. 0.68. What is the ratio of the Net enrolment rate(%) of Ukraine in 2000 to that in 2008?
Make the answer very short. 1.05. What is the ratio of the Net enrolment rate(%) in Luxembourg in 2000 to that in 2010?
Provide a short and direct response. 0.96. What is the ratio of the Net enrolment rate(%) of Mexico in 2000 to that in 2010?
Offer a terse response. 0.84. What is the ratio of the Net enrolment rate(%) in St. Vincent and the Grenadines in 2000 to that in 2010?
Your answer should be compact. 0.69. What is the ratio of the Net enrolment rate(%) of Ukraine in 2000 to that in 2010?
Offer a very short reply. 1.04. What is the ratio of the Net enrolment rate(%) in Luxembourg in 2002 to that in 2003?
Keep it short and to the point. 1. What is the ratio of the Net enrolment rate(%) in Mexico in 2002 to that in 2003?
Your response must be concise. 0.96. What is the ratio of the Net enrolment rate(%) of St. Vincent and the Grenadines in 2002 to that in 2003?
Provide a short and direct response. 0.96. What is the ratio of the Net enrolment rate(%) of Ukraine in 2002 to that in 2003?
Offer a terse response. 0.99. What is the ratio of the Net enrolment rate(%) in Luxembourg in 2002 to that in 2004?
Provide a short and direct response. 1. What is the ratio of the Net enrolment rate(%) in Mexico in 2002 to that in 2004?
Your answer should be very brief. 0.94. What is the ratio of the Net enrolment rate(%) in St. Vincent and the Grenadines in 2002 to that in 2004?
Ensure brevity in your answer.  0.92. What is the ratio of the Net enrolment rate(%) in Ukraine in 2002 to that in 2004?
Provide a succinct answer. 1. What is the ratio of the Net enrolment rate(%) of Luxembourg in 2002 to that in 2005?
Give a very brief answer. 0.96. What is the ratio of the Net enrolment rate(%) of Mexico in 2002 to that in 2005?
Make the answer very short. 0.92. What is the ratio of the Net enrolment rate(%) of St. Vincent and the Grenadines in 2002 to that in 2005?
Your answer should be very brief. 1.05. What is the ratio of the Net enrolment rate(%) of Ukraine in 2002 to that in 2005?
Offer a very short reply. 1.01. What is the ratio of the Net enrolment rate(%) of Luxembourg in 2002 to that in 2008?
Your answer should be very brief. 0.93. What is the ratio of the Net enrolment rate(%) of Mexico in 2002 to that in 2008?
Give a very brief answer. 0.89. What is the ratio of the Net enrolment rate(%) in St. Vincent and the Grenadines in 2002 to that in 2008?
Offer a very short reply. 0.78. What is the ratio of the Net enrolment rate(%) in Ukraine in 2002 to that in 2008?
Keep it short and to the point. 1.01. What is the ratio of the Net enrolment rate(%) in Luxembourg in 2002 to that in 2010?
Provide a short and direct response. 0.91. What is the ratio of the Net enrolment rate(%) in Mexico in 2002 to that in 2010?
Your response must be concise. 0.9. What is the ratio of the Net enrolment rate(%) of St. Vincent and the Grenadines in 2002 to that in 2010?
Offer a very short reply. 0.79. What is the ratio of the Net enrolment rate(%) of Mexico in 2003 to that in 2004?
Give a very brief answer. 0.98. What is the ratio of the Net enrolment rate(%) in St. Vincent and the Grenadines in 2003 to that in 2004?
Give a very brief answer. 0.96. What is the ratio of the Net enrolment rate(%) in Luxembourg in 2003 to that in 2005?
Your answer should be very brief. 0.97. What is the ratio of the Net enrolment rate(%) of Mexico in 2003 to that in 2005?
Keep it short and to the point. 0.96. What is the ratio of the Net enrolment rate(%) in St. Vincent and the Grenadines in 2003 to that in 2005?
Your answer should be compact. 1.09. What is the ratio of the Net enrolment rate(%) in Ukraine in 2003 to that in 2005?
Offer a terse response. 1.02. What is the ratio of the Net enrolment rate(%) in Luxembourg in 2003 to that in 2008?
Provide a short and direct response. 0.93. What is the ratio of the Net enrolment rate(%) of Mexico in 2003 to that in 2008?
Your answer should be very brief. 0.93. What is the ratio of the Net enrolment rate(%) in St. Vincent and the Grenadines in 2003 to that in 2008?
Your answer should be compact. 0.81. What is the ratio of the Net enrolment rate(%) in Ukraine in 2003 to that in 2008?
Offer a very short reply. 1.02. What is the ratio of the Net enrolment rate(%) of Luxembourg in 2003 to that in 2010?
Make the answer very short. 0.92. What is the ratio of the Net enrolment rate(%) in Mexico in 2003 to that in 2010?
Ensure brevity in your answer.  0.93. What is the ratio of the Net enrolment rate(%) of St. Vincent and the Grenadines in 2003 to that in 2010?
Offer a terse response. 0.82. What is the ratio of the Net enrolment rate(%) in Ukraine in 2003 to that in 2010?
Offer a terse response. 1.01. What is the ratio of the Net enrolment rate(%) of Luxembourg in 2004 to that in 2005?
Offer a terse response. 0.96. What is the ratio of the Net enrolment rate(%) of Mexico in 2004 to that in 2005?
Make the answer very short. 0.98. What is the ratio of the Net enrolment rate(%) in St. Vincent and the Grenadines in 2004 to that in 2005?
Your answer should be compact. 1.14. What is the ratio of the Net enrolment rate(%) of Ukraine in 2004 to that in 2005?
Your answer should be very brief. 1.01. What is the ratio of the Net enrolment rate(%) in Luxembourg in 2004 to that in 2008?
Offer a very short reply. 0.93. What is the ratio of the Net enrolment rate(%) of Mexico in 2004 to that in 2008?
Provide a short and direct response. 0.95. What is the ratio of the Net enrolment rate(%) in St. Vincent and the Grenadines in 2004 to that in 2008?
Provide a short and direct response. 0.84. What is the ratio of the Net enrolment rate(%) in Ukraine in 2004 to that in 2008?
Your answer should be very brief. 1.01. What is the ratio of the Net enrolment rate(%) of Mexico in 2004 to that in 2010?
Your response must be concise. 0.95. What is the ratio of the Net enrolment rate(%) in St. Vincent and the Grenadines in 2004 to that in 2010?
Provide a short and direct response. 0.86. What is the ratio of the Net enrolment rate(%) in Luxembourg in 2005 to that in 2008?
Make the answer very short. 0.96. What is the ratio of the Net enrolment rate(%) of Mexico in 2005 to that in 2008?
Offer a terse response. 0.97. What is the ratio of the Net enrolment rate(%) in St. Vincent and the Grenadines in 2005 to that in 2008?
Give a very brief answer. 0.74. What is the ratio of the Net enrolment rate(%) of Luxembourg in 2005 to that in 2010?
Offer a very short reply. 0.95. What is the ratio of the Net enrolment rate(%) in Mexico in 2005 to that in 2010?
Give a very brief answer. 0.97. What is the ratio of the Net enrolment rate(%) in St. Vincent and the Grenadines in 2005 to that in 2010?
Offer a terse response. 0.76. What is the ratio of the Net enrolment rate(%) of Ukraine in 2005 to that in 2010?
Keep it short and to the point. 0.99. What is the ratio of the Net enrolment rate(%) of Luxembourg in 2008 to that in 2010?
Keep it short and to the point. 0.98. What is the ratio of the Net enrolment rate(%) of St. Vincent and the Grenadines in 2008 to that in 2010?
Offer a very short reply. 1.02. What is the difference between the highest and the second highest Net enrolment rate(%) in Luxembourg?
Your answer should be compact. 1.44. What is the difference between the highest and the second highest Net enrolment rate(%) of Mexico?
Give a very brief answer. 0.17. What is the difference between the highest and the second highest Net enrolment rate(%) of St. Vincent and the Grenadines?
Make the answer very short. 1.47. What is the difference between the highest and the second highest Net enrolment rate(%) in Ukraine?
Provide a short and direct response. 2.33. What is the difference between the highest and the lowest Net enrolment rate(%) in Luxembourg?
Ensure brevity in your answer.  7.42. What is the difference between the highest and the lowest Net enrolment rate(%) of Mexico?
Your response must be concise. 10.74. What is the difference between the highest and the lowest Net enrolment rate(%) in St. Vincent and the Grenadines?
Your response must be concise. 27.73. What is the difference between the highest and the lowest Net enrolment rate(%) in Ukraine?
Provide a succinct answer. 3.87. 